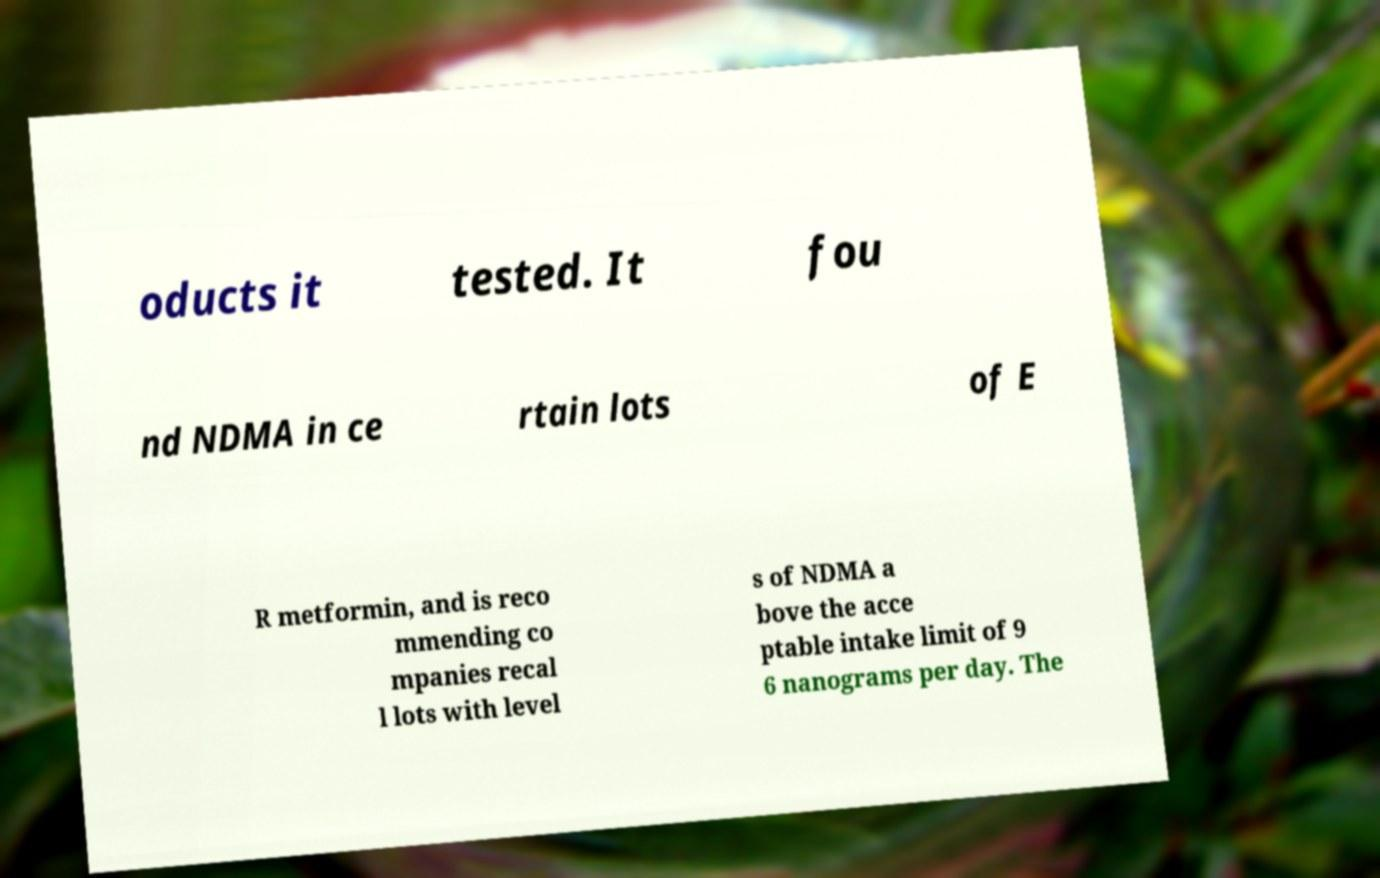Can you read and provide the text displayed in the image?This photo seems to have some interesting text. Can you extract and type it out for me? oducts it tested. It fou nd NDMA in ce rtain lots of E R metformin, and is reco mmending co mpanies recal l lots with level s of NDMA a bove the acce ptable intake limit of 9 6 nanograms per day. The 